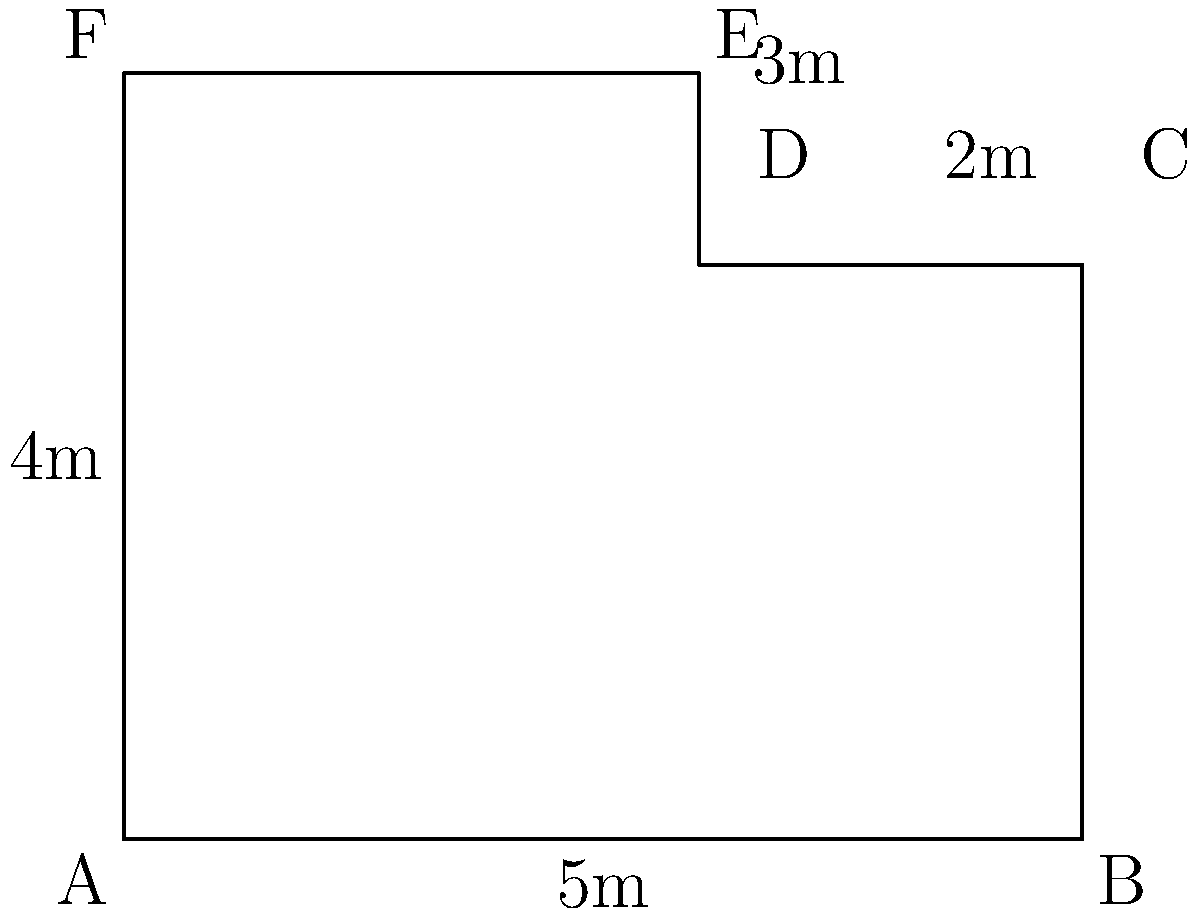You're designing a nursery room with an irregular shape as shown in the diagram. Calculate the total floor area of the nursery to determine how much flooring material you'll need to purchase. All measurements are in meters. To calculate the total floor area, we'll divide the room into two rectangles and add their areas:

1. Rectangle ABCDF:
   Length = 5m, Width = 3m
   Area of ABCDF = $5m \times 3m = 15m^2$

2. Rectangle DEF:
   Length = 3m, Width = 1m
   Area of DEF = $3m \times 1m = 3m^2$

3. Total area:
   $\text{Total Area} = \text{Area of ABCDF} + \text{Area of DEF}$
   $\text{Total Area} = 15m^2 + 3m^2 = 18m^2$

Therefore, the total floor area of the nursery is $18m^2$.
Answer: $18m^2$ 